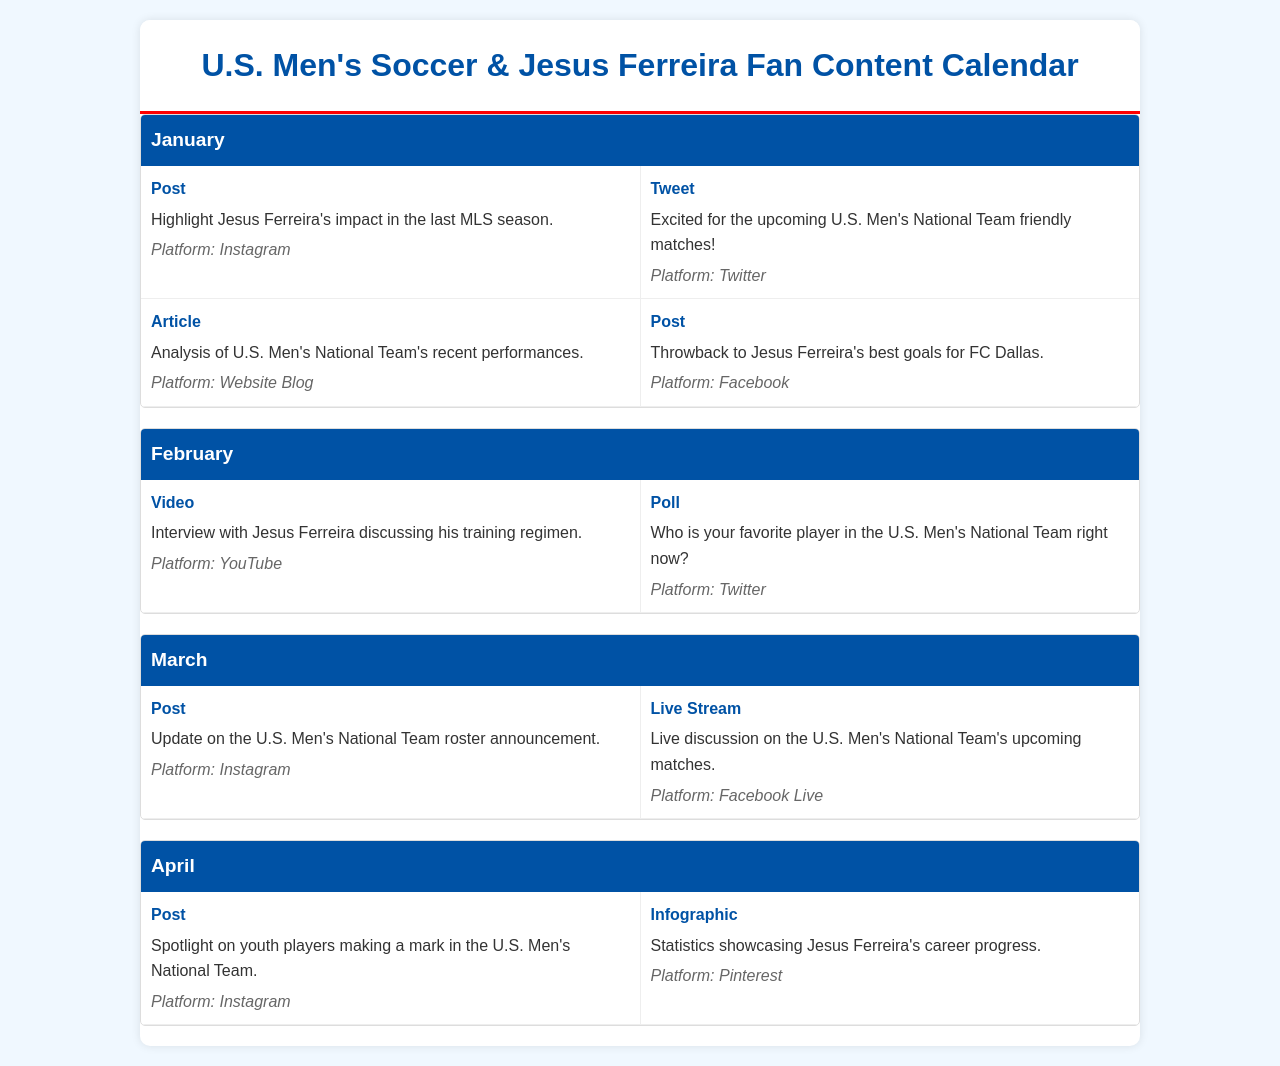What month features a tweet about the U.S. Men's National Team friendly matches? The document lists posts by content type under each month, and the tweet about the U.S. Men's National Team is in January.
Answer: January What platform is used for Jesus Ferreira's training regimen interview? The document specifies the platform for each content type, and the interview is on YouTube.
Answer: YouTube How many pieces of content are scheduled for March? By counting the content types listed under March, we see there are two pieces of content planned.
Answer: 2 What type of content is featured with statistics about Jesus Ferreira's career? The document specifies the content type for each entry, and the statistics are presented as an infographic.
Answer: Infographic Which month includes a live discussion about upcoming matches? The document outlines the content for each month, and the live discussion is scheduled for March.
Answer: March In which month is the spotlight on youth players mentioned? The spotlight on youth players is highlighted in the content list for April.
Answer: April What social media platform is used to showcase a throwback to Jesus Ferreira's best goals? The specified platform for this throwback post is Facebook.
Answer: Facebook Which content type is used for discussing the U.S. Men's National Team roster announcement? The document categorizes the content types, and the roster announcement is a post.
Answer: Post What content type is scheduled for February 2nd in the document? Analyzing the content listed under February, it's clear that the second entry is a poll.
Answer: Poll 